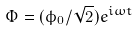<formula> <loc_0><loc_0><loc_500><loc_500>\Phi = ( \phi _ { 0 } / { \sqrt { 2 } } ) e ^ { i \omega t }</formula> 